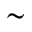Convert formula to latex. <formula><loc_0><loc_0><loc_500><loc_500>\sim</formula> 